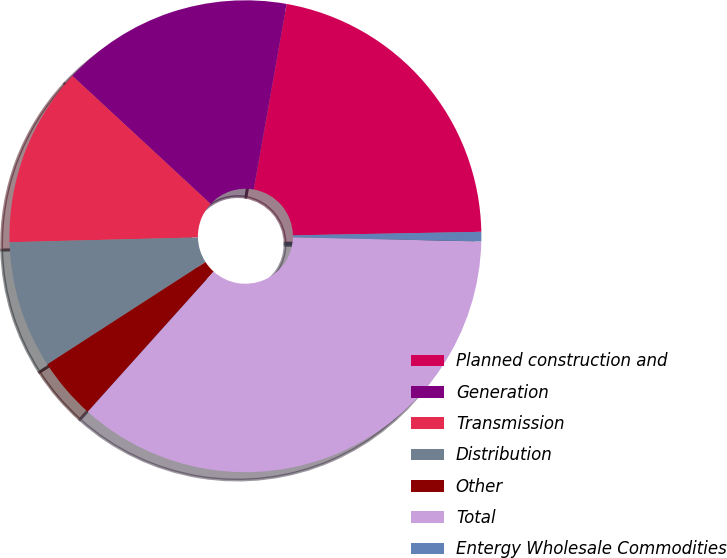<chart> <loc_0><loc_0><loc_500><loc_500><pie_chart><fcel>Planned construction and<fcel>Generation<fcel>Transmission<fcel>Distribution<fcel>Other<fcel>Total<fcel>Entergy Wholesale Commodities<nl><fcel>21.91%<fcel>15.9%<fcel>12.3%<fcel>8.73%<fcel>4.22%<fcel>36.3%<fcel>0.65%<nl></chart> 